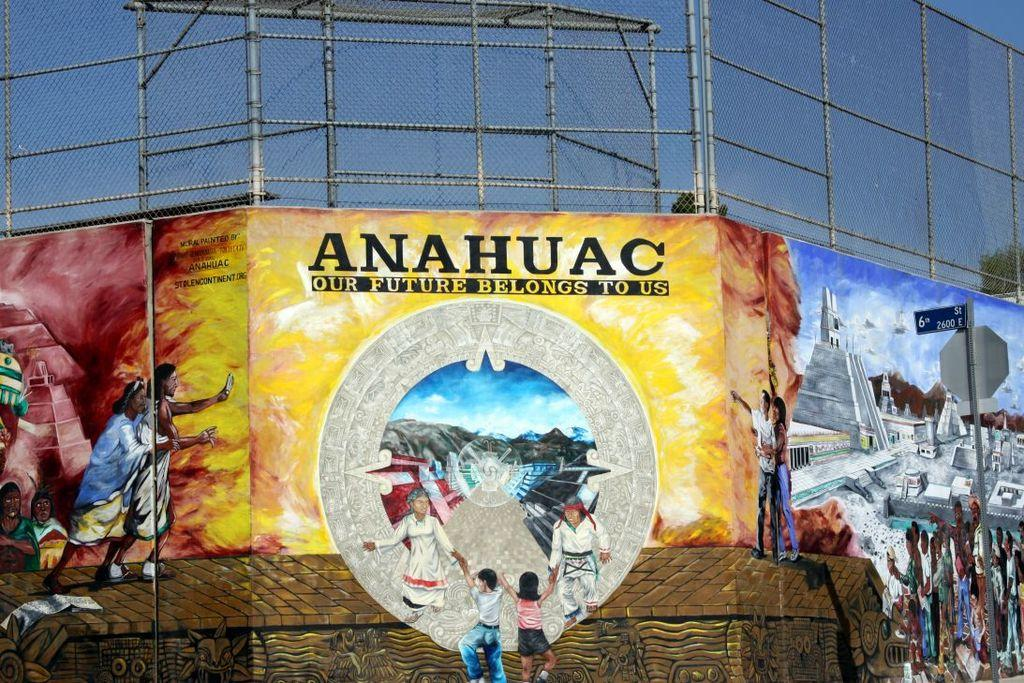<image>
Render a clear and concise summary of the photo. A sign proclaiming that the future belongs to us is represented by stunning street art that showcases multiple themes. 